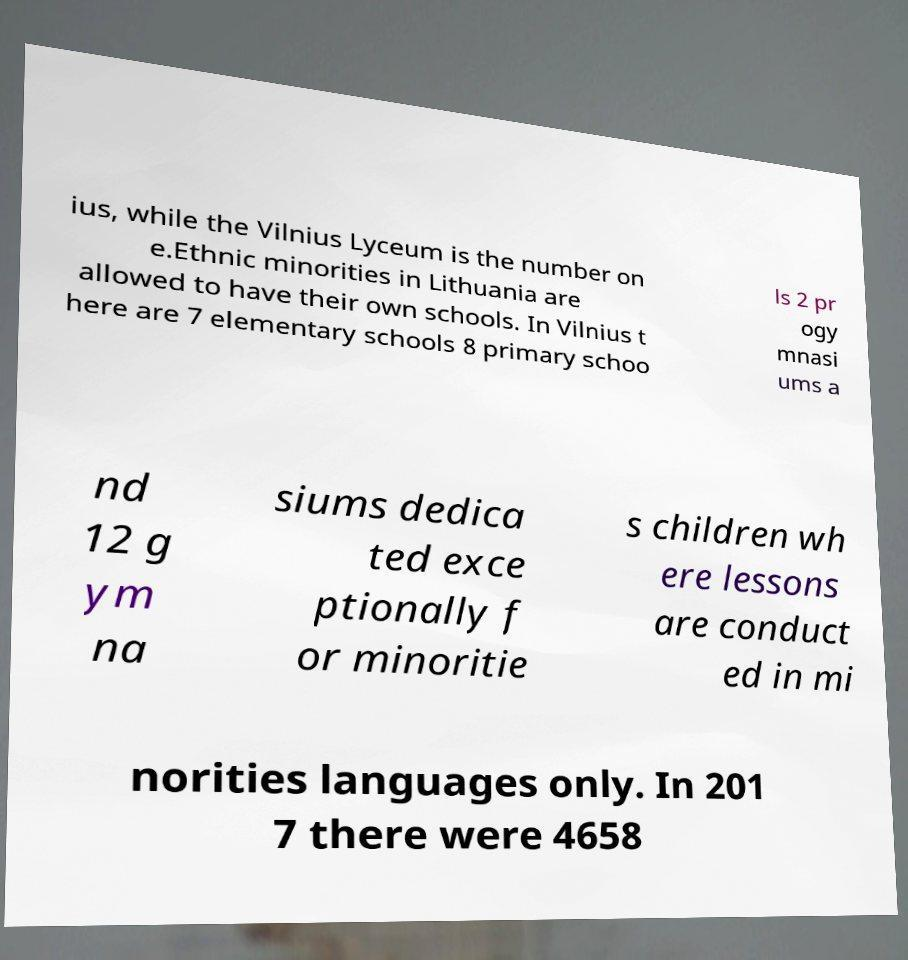Could you extract and type out the text from this image? ius, while the Vilnius Lyceum is the number on e.Ethnic minorities in Lithuania are allowed to have their own schools. In Vilnius t here are 7 elementary schools 8 primary schoo ls 2 pr ogy mnasi ums a nd 12 g ym na siums dedica ted exce ptionally f or minoritie s children wh ere lessons are conduct ed in mi norities languages only. In 201 7 there were 4658 